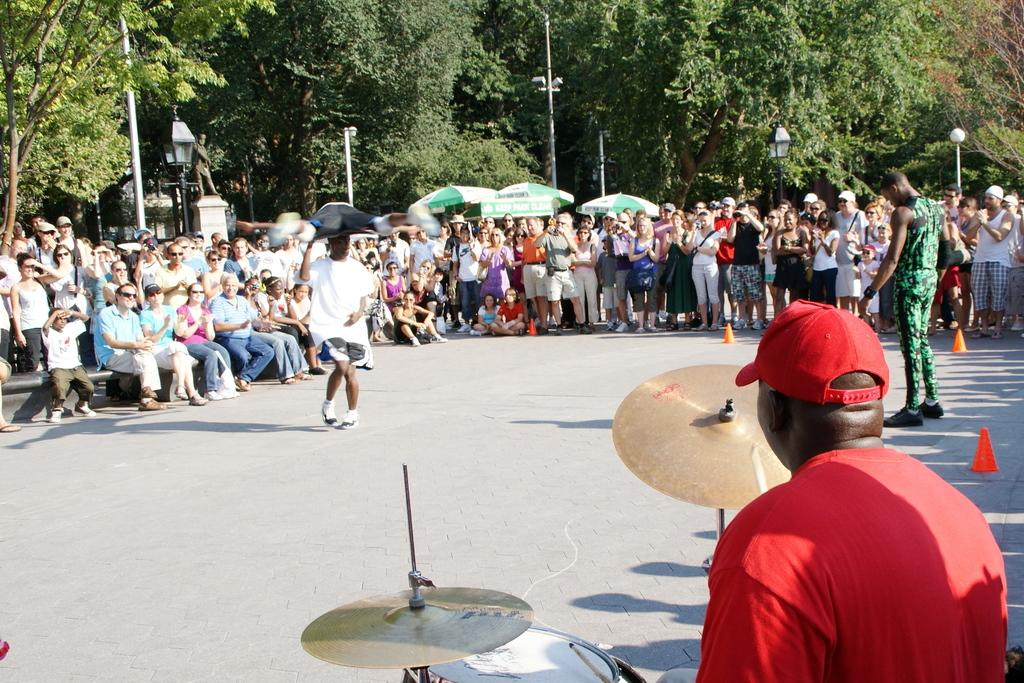What is the main activity being performed by the person in the image? There is a person playing the drum in the image. Are there any other people present in the image? Yes, there are other people in the image. What objects can be seen in the background of the image? There are poles and trees in the image. What type of steel is being used to construct the cow in the image? There is no cow present in the image, and therefore no steel construction can be observed. 